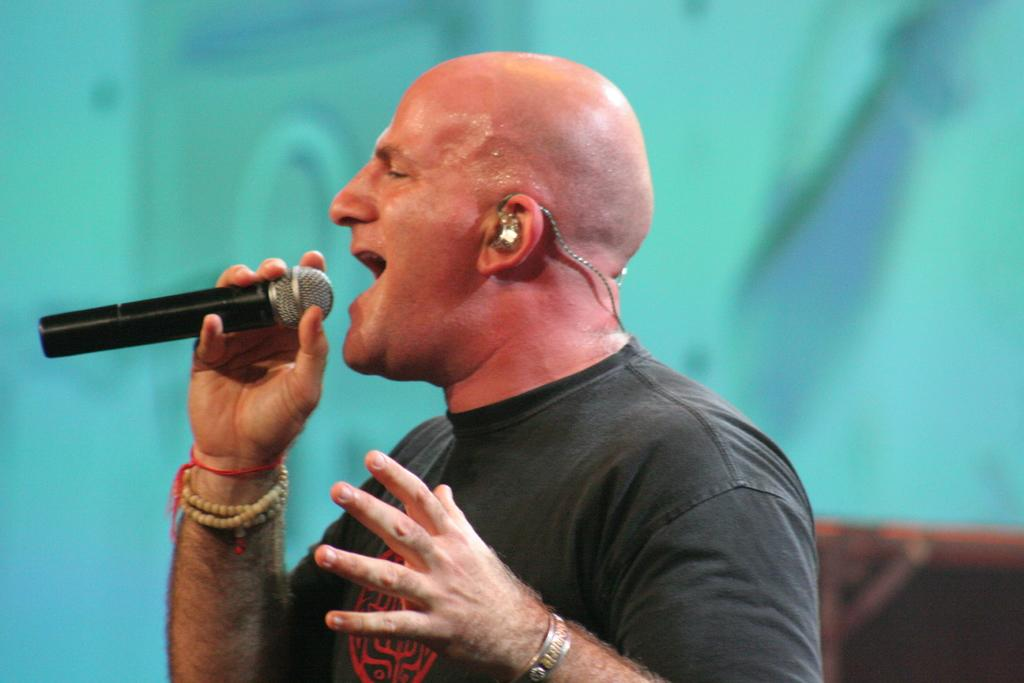What is the man in the image holding? The man is holding a mic in the image. What can be seen in the background of the image? There are objects in the background of the image. How would you describe the background of the image? The background is blurry. What theory is the robin discussing in the morning in the image? There is no robin or discussion of a theory in the image; it features a man holding a mic with a blurry background. 